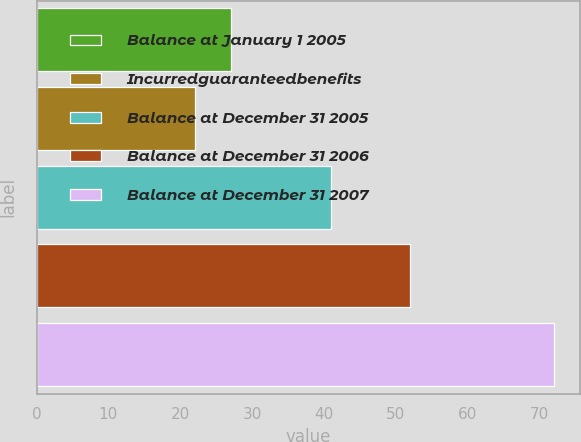Convert chart to OTSL. <chart><loc_0><loc_0><loc_500><loc_500><bar_chart><fcel>Balance at January 1 2005<fcel>Incurredguaranteedbenefits<fcel>Balance at December 31 2005<fcel>Balance at December 31 2006<fcel>Balance at December 31 2007<nl><fcel>27<fcel>22<fcel>41<fcel>52<fcel>72<nl></chart> 